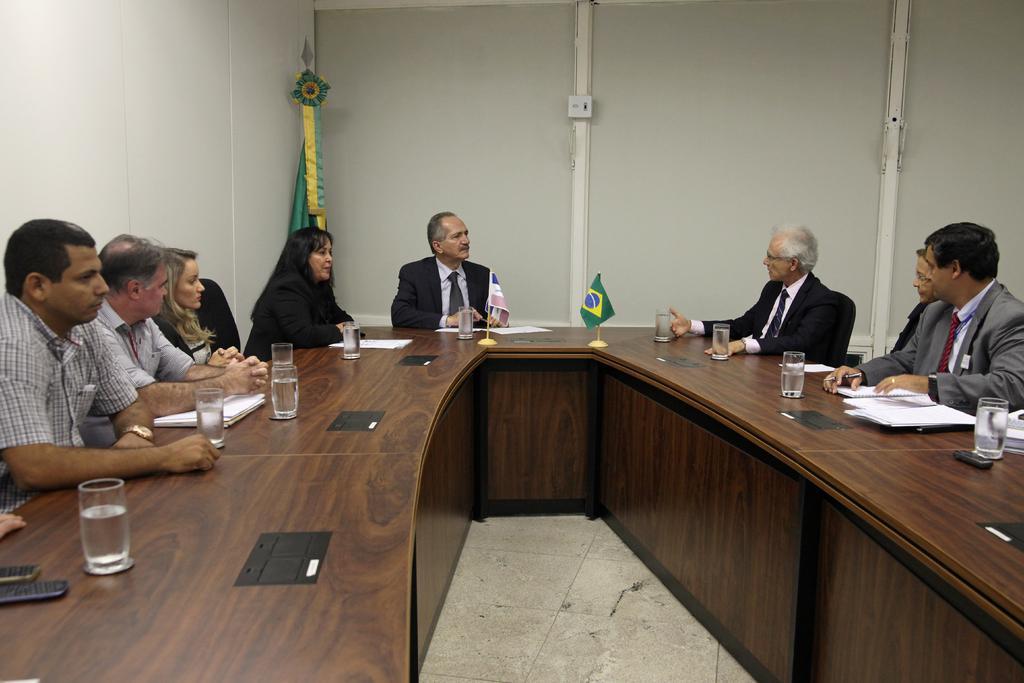Please provide a concise description of this image. This image is clicked in a meeting. Here are eight people sitting around the table. On the table, we can see glass, mobile phones, book and a flag. On the right of this picture, three people sat on the chair. On the left, we can see five people and these people are looking to the one who is sitting on the right and talking. Behind them, we can see white wall and green flag. 